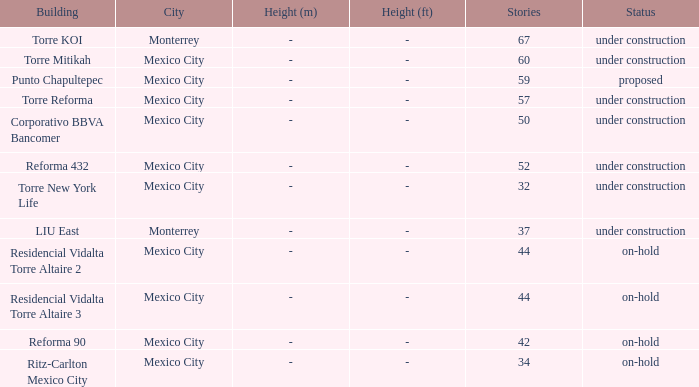How many stories is the torre reforma building? 1.0. 